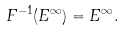Convert formula to latex. <formula><loc_0><loc_0><loc_500><loc_500>F ^ { - 1 } ( E ^ { \infty } ) = E ^ { \infty } .</formula> 